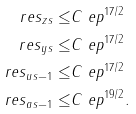<formula> <loc_0><loc_0><loc_500><loc_500>\| \ r e s _ { z } \| _ { s } \leq & C \ e p ^ { 1 7 / 2 } \\ \| \ r e s _ { y } \| _ { s } \leq & C \ e p ^ { 1 7 / 2 } \\ \| \ r e s _ { u } \| _ { s - 1 } \leq & C \ e p ^ { 1 7 / 2 } \\ \| \ r e s _ { a } \| _ { s - 1 } \leq & C \ e p ^ { 1 9 / 2 } .</formula> 